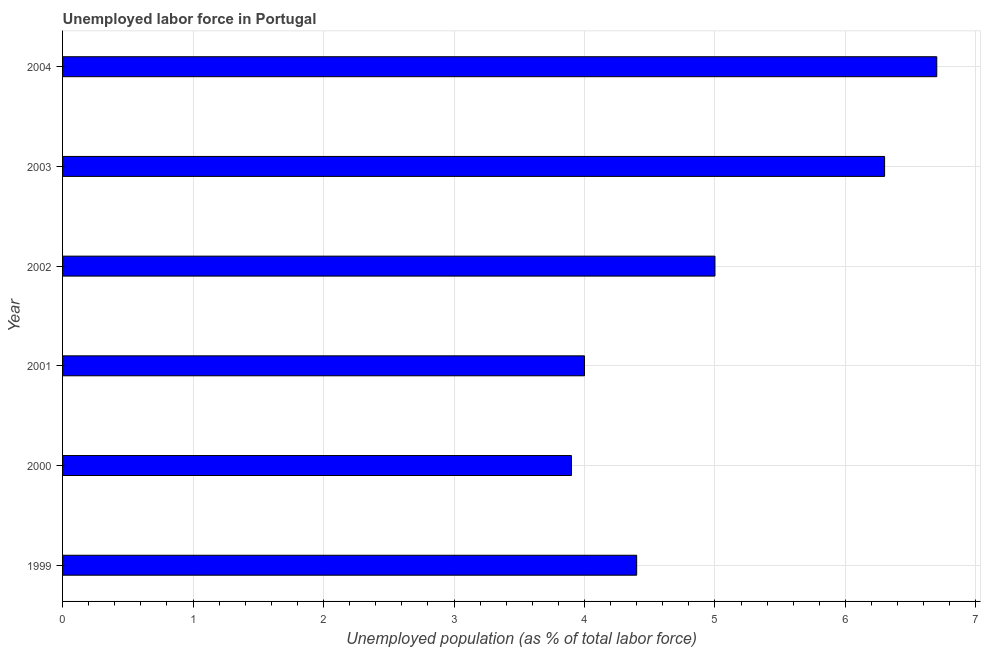Does the graph contain any zero values?
Offer a terse response. No. What is the title of the graph?
Provide a short and direct response. Unemployed labor force in Portugal. What is the label or title of the X-axis?
Your answer should be very brief. Unemployed population (as % of total labor force). What is the label or title of the Y-axis?
Keep it short and to the point. Year. What is the total unemployed population in 1999?
Keep it short and to the point. 4.4. Across all years, what is the maximum total unemployed population?
Provide a succinct answer. 6.7. Across all years, what is the minimum total unemployed population?
Ensure brevity in your answer.  3.9. In which year was the total unemployed population maximum?
Make the answer very short. 2004. What is the sum of the total unemployed population?
Your answer should be compact. 30.3. What is the difference between the total unemployed population in 1999 and 2001?
Provide a succinct answer. 0.4. What is the average total unemployed population per year?
Give a very brief answer. 5.05. What is the median total unemployed population?
Offer a terse response. 4.7. In how many years, is the total unemployed population greater than 2.8 %?
Your answer should be compact. 6. What is the ratio of the total unemployed population in 2000 to that in 2001?
Give a very brief answer. 0.97. Is the difference between the total unemployed population in 1999 and 2001 greater than the difference between any two years?
Keep it short and to the point. No. What is the difference between the highest and the second highest total unemployed population?
Give a very brief answer. 0.4. Is the sum of the total unemployed population in 2000 and 2003 greater than the maximum total unemployed population across all years?
Offer a very short reply. Yes. How many years are there in the graph?
Your response must be concise. 6. What is the difference between two consecutive major ticks on the X-axis?
Offer a very short reply. 1. Are the values on the major ticks of X-axis written in scientific E-notation?
Keep it short and to the point. No. What is the Unemployed population (as % of total labor force) in 1999?
Provide a short and direct response. 4.4. What is the Unemployed population (as % of total labor force) in 2000?
Provide a short and direct response. 3.9. What is the Unemployed population (as % of total labor force) of 2001?
Provide a short and direct response. 4. What is the Unemployed population (as % of total labor force) of 2002?
Offer a terse response. 5. What is the Unemployed population (as % of total labor force) in 2003?
Give a very brief answer. 6.3. What is the Unemployed population (as % of total labor force) in 2004?
Your answer should be compact. 6.7. What is the difference between the Unemployed population (as % of total labor force) in 2000 and 2002?
Your answer should be very brief. -1.1. What is the difference between the Unemployed population (as % of total labor force) in 2001 and 2002?
Provide a short and direct response. -1. What is the difference between the Unemployed population (as % of total labor force) in 2001 and 2003?
Give a very brief answer. -2.3. What is the ratio of the Unemployed population (as % of total labor force) in 1999 to that in 2000?
Offer a very short reply. 1.13. What is the ratio of the Unemployed population (as % of total labor force) in 1999 to that in 2002?
Provide a succinct answer. 0.88. What is the ratio of the Unemployed population (as % of total labor force) in 1999 to that in 2003?
Offer a terse response. 0.7. What is the ratio of the Unemployed population (as % of total labor force) in 1999 to that in 2004?
Ensure brevity in your answer.  0.66. What is the ratio of the Unemployed population (as % of total labor force) in 2000 to that in 2001?
Ensure brevity in your answer.  0.97. What is the ratio of the Unemployed population (as % of total labor force) in 2000 to that in 2002?
Offer a terse response. 0.78. What is the ratio of the Unemployed population (as % of total labor force) in 2000 to that in 2003?
Give a very brief answer. 0.62. What is the ratio of the Unemployed population (as % of total labor force) in 2000 to that in 2004?
Your response must be concise. 0.58. What is the ratio of the Unemployed population (as % of total labor force) in 2001 to that in 2003?
Keep it short and to the point. 0.64. What is the ratio of the Unemployed population (as % of total labor force) in 2001 to that in 2004?
Ensure brevity in your answer.  0.6. What is the ratio of the Unemployed population (as % of total labor force) in 2002 to that in 2003?
Your response must be concise. 0.79. What is the ratio of the Unemployed population (as % of total labor force) in 2002 to that in 2004?
Your answer should be very brief. 0.75. What is the ratio of the Unemployed population (as % of total labor force) in 2003 to that in 2004?
Ensure brevity in your answer.  0.94. 